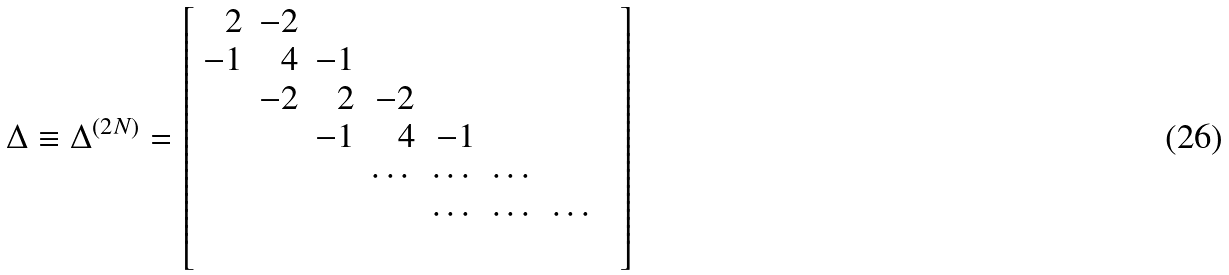Convert formula to latex. <formula><loc_0><loc_0><loc_500><loc_500>\Delta \equiv \Delta ^ { ( 2 N ) } = \left [ \begin{array} { r r r r r r r r } 2 & - 2 & & & & & & \\ - 1 & 4 & - 1 & & & & & \\ & - 2 & 2 & - 2 & & & & \\ & & - 1 & 4 & - 1 & & & \\ & & & \cdots & \cdots & \cdots & & \\ & & & & \cdots & \cdots & \cdots & \\ \\ \end{array} \right ]</formula> 